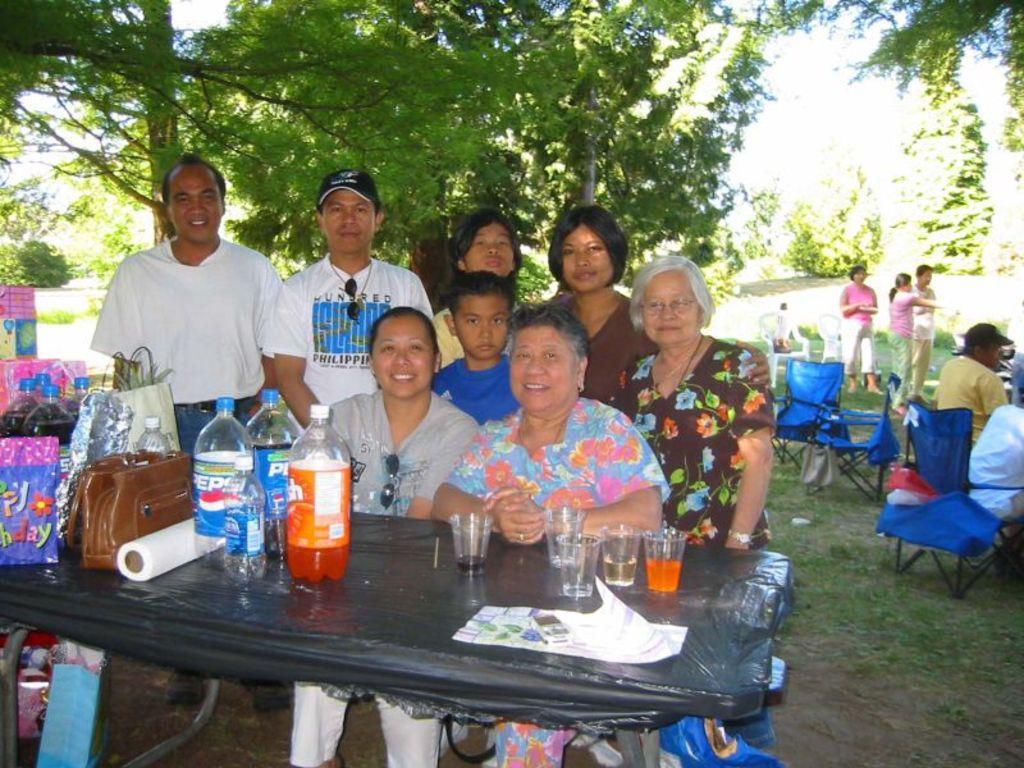How would you summarize this image in a sentence or two? On the background we can see trees and few persons standing. We can see empty chairs in front of a table giving pose to the camera and they all hold a pretty smile on their faces. On the table we can see preservative bottles, drinking glasses, paper, handbags, carry bags. Under the table we can see carry bag. 